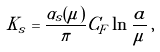<formula> <loc_0><loc_0><loc_500><loc_500>K _ { s } = \frac { \alpha _ { s } ( \mu ) } { \pi } C _ { F } \ln \frac { a } { \mu } \, ,</formula> 